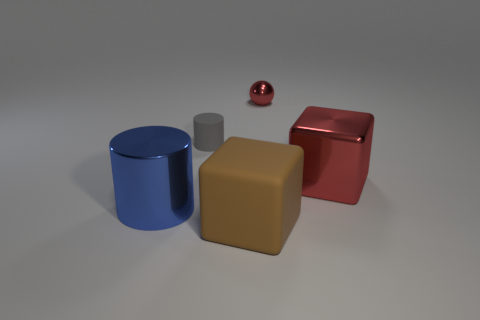What shape is the shiny thing that is both left of the red cube and on the right side of the blue metallic object?
Keep it short and to the point. Sphere. How many big brown objects are to the left of the matte object on the left side of the big thing in front of the blue thing?
Your response must be concise. 0. The other object that is the same shape as the blue thing is what size?
Provide a short and direct response. Small. Is there anything else that is the same size as the brown block?
Provide a short and direct response. Yes. Is the material of the large thing that is in front of the big cylinder the same as the large cylinder?
Provide a short and direct response. No. What is the color of the other object that is the same shape as the big blue metal object?
Your answer should be very brief. Gray. How many other objects are there of the same color as the tiny rubber thing?
Offer a terse response. 0. Does the rubber object that is behind the large blue metallic object have the same shape as the red object behind the small gray matte cylinder?
Provide a short and direct response. No. What number of cubes are red shiny things or big red shiny objects?
Offer a terse response. 1. Are there fewer tiny cylinders right of the brown rubber thing than tiny cyan metallic cubes?
Provide a short and direct response. No. 